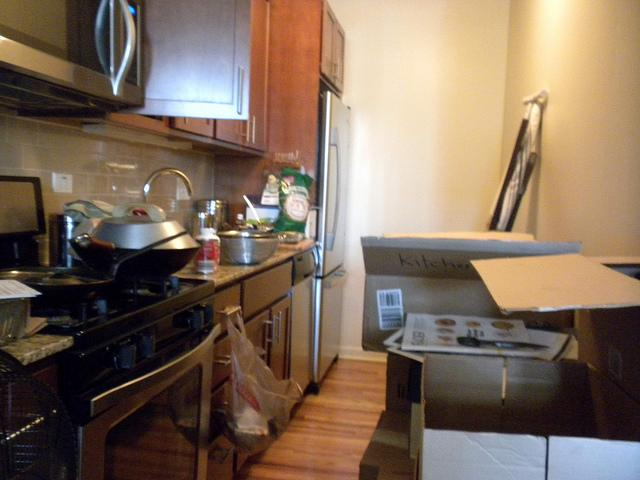What does the cardboard box tell us about this situation? moving 